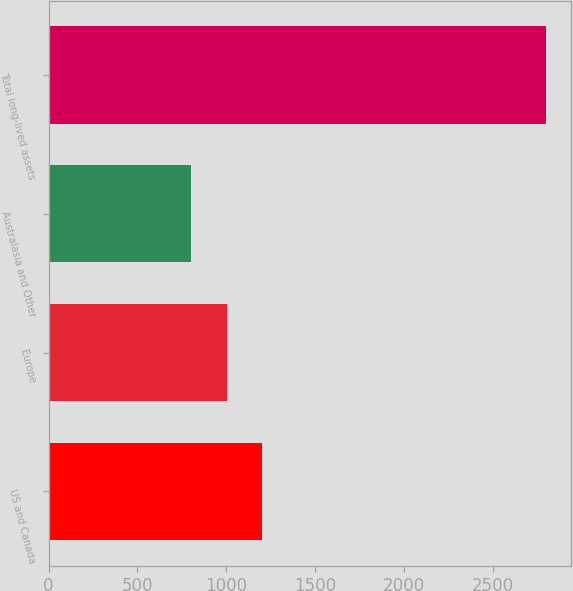Convert chart to OTSL. <chart><loc_0><loc_0><loc_500><loc_500><bar_chart><fcel>US and Canada<fcel>Europe<fcel>Australasia and Other<fcel>Total long-lived assets<nl><fcel>1203.4<fcel>1003.7<fcel>804<fcel>2801<nl></chart> 